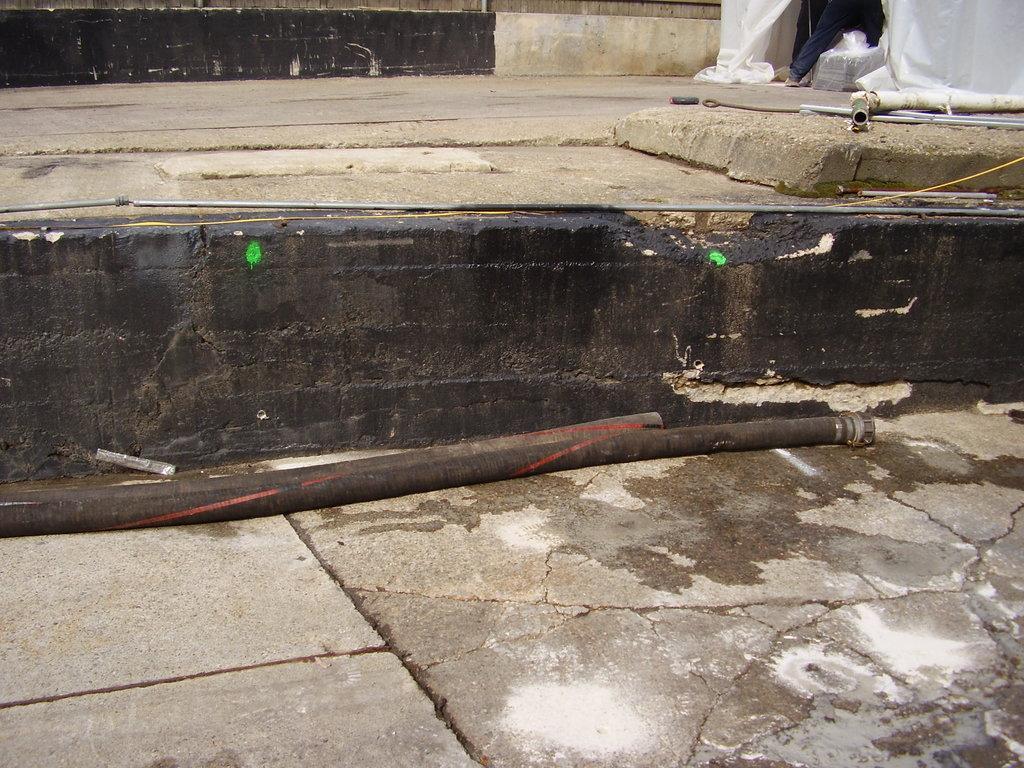How would you summarize this image in a sentence or two? In the image two pipes are there. At the right top most of the image a person is standing. 